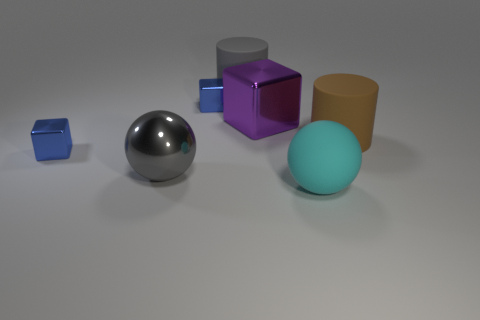Add 2 tiny yellow cubes. How many objects exist? 9 Subtract all cubes. How many objects are left? 4 Subtract all gray objects. Subtract all cyan balls. How many objects are left? 4 Add 5 purple metal objects. How many purple metal objects are left? 6 Add 7 small blue metal blocks. How many small blue metal blocks exist? 9 Subtract 0 purple cylinders. How many objects are left? 7 